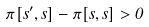Convert formula to latex. <formula><loc_0><loc_0><loc_500><loc_500>\pi [ s ^ { \prime } , s ] - \pi [ s , s ] > 0</formula> 